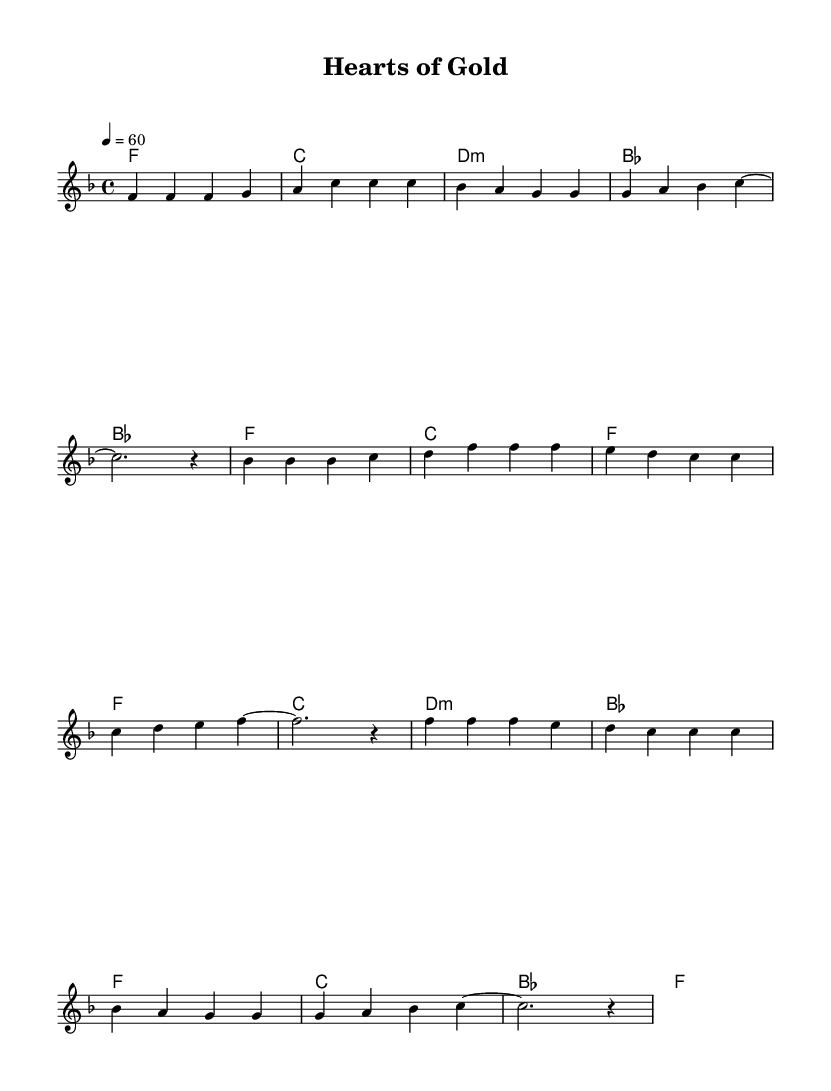What is the key signature of this music? The key signature is F major, which has one flat (B flat). This is determined by looking at the key signature indicated at the beginning of the staff.
Answer: F major What is the time signature of this music? The time signature is 4/4, which means there are four beats per measure and the quarter note gets one beat. This is indicated at the beginning of the piece next to the key signature.
Answer: 4/4 What is the tempo marking of this music? The tempo marking is 60 beats per minute, indicated by the text "4 = 60" in the upper part of the score. This signifies a slow pace for the piece.
Answer: 60 How many measures are in the verse section? The verse section consists of four measures, which can be counted by looking at the grouping of notes and bars in the melody part of the score.
Answer: 4 What is the first chord of the pre-chorus? The first chord of the pre-chorus is B flat major, which is identified in the chord progression listed before the melody.
Answer: B flat Which chord comes after D minor in the chorus? The chord that comes after D minor in the chorus is B flat major, as seen in the chord sequence under the melody for the chorus part.
Answer: B flat What emotional atmosphere might this music convey based on its characteristics? The music conveys a romantic atmosphere, characterized by its slow tempo, major key, and the soaring melodies typical of power ballads from the 1980s.
Answer: Romantic 